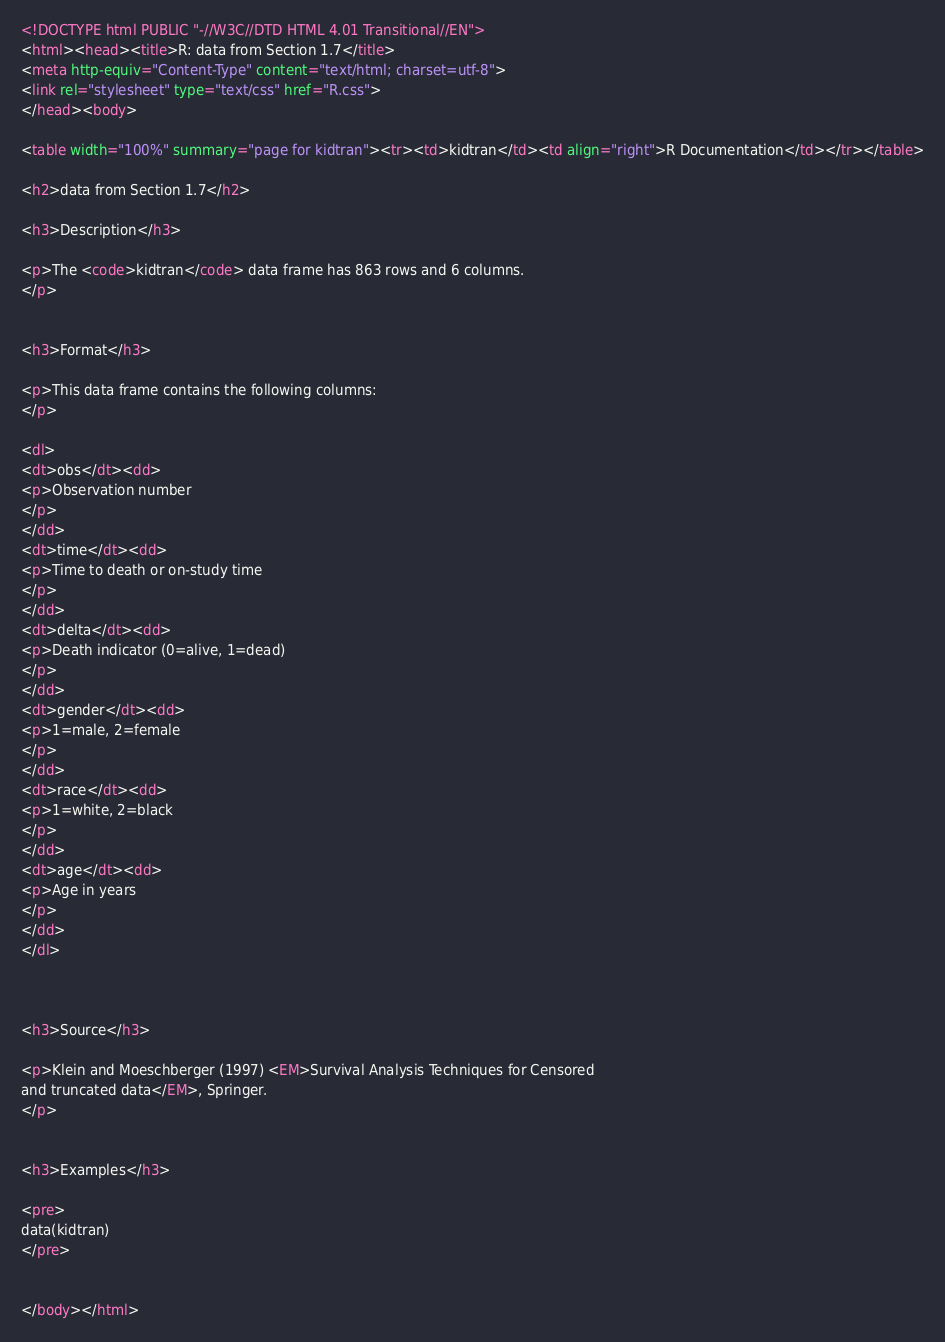<code> <loc_0><loc_0><loc_500><loc_500><_HTML_><!DOCTYPE html PUBLIC "-//W3C//DTD HTML 4.01 Transitional//EN">
<html><head><title>R: data from Section 1.7</title>
<meta http-equiv="Content-Type" content="text/html; charset=utf-8">
<link rel="stylesheet" type="text/css" href="R.css">
</head><body>

<table width="100%" summary="page for kidtran"><tr><td>kidtran</td><td align="right">R Documentation</td></tr></table>

<h2>data from Section 1.7</h2>

<h3>Description</h3>

<p>The <code>kidtran</code> data frame has 863 rows and 6 columns.
</p>


<h3>Format</h3>

<p>This data frame contains the following columns:
</p>

<dl>
<dt>obs</dt><dd>
<p>Observation number
</p>
</dd>
<dt>time</dt><dd>
<p>Time to death or on-study time
</p>
</dd>
<dt>delta</dt><dd>
<p>Death indicator (0=alive, 1=dead)
</p>
</dd>
<dt>gender</dt><dd>
<p>1=male, 2=female
</p>
</dd>
<dt>race</dt><dd>
<p>1=white, 2=black
</p>
</dd>
<dt>age</dt><dd>
<p>Age in years
</p>
</dd>
</dl>



<h3>Source</h3>

<p>Klein and Moeschberger (1997) <EM>Survival Analysis Techniques for Censored
and truncated data</EM>, Springer.
</p>


<h3>Examples</h3>

<pre>
data(kidtran)
</pre>


</body></html>
</code> 